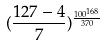Convert formula to latex. <formula><loc_0><loc_0><loc_500><loc_500>( \frac { 1 2 7 - 4 } { 7 } ) ^ { \frac { 1 0 0 ^ { 1 6 8 } } { 3 7 0 } }</formula> 